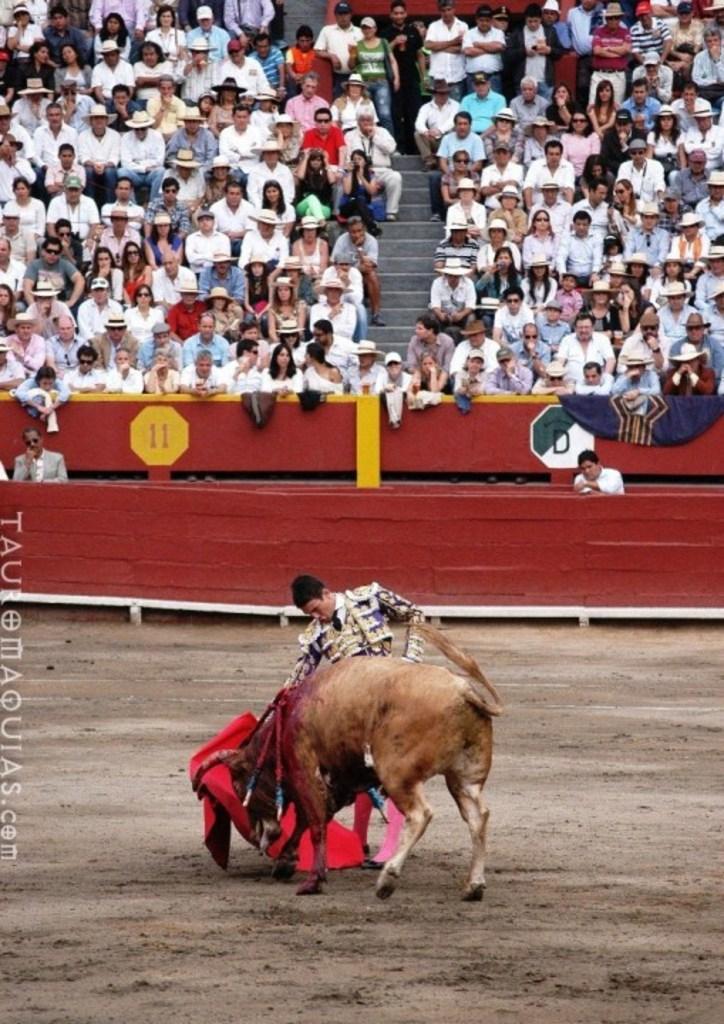Could you give a brief overview of what you see in this image? This image consists of a bull in brown color. Beside that there is a man standing. At the bottom, there is a ground. In the background, we can see a huge crowd. And there is a fencing made up of wood in red color. 